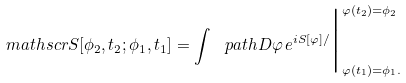Convert formula to latex. <formula><loc_0><loc_0><loc_500><loc_500>\ m a t h s c r { S } [ \phi _ { 2 } , t _ { 2 } ; \phi _ { 1 } , t _ { 1 } ] = \int \ p a t h D \varphi \, e ^ { i S [ \varphi ] / } \Big | ^ { \varphi ( t _ { 2 } ) = \phi _ { 2 } } _ { \varphi ( t _ { 1 } ) = \phi _ { 1 } . }</formula> 